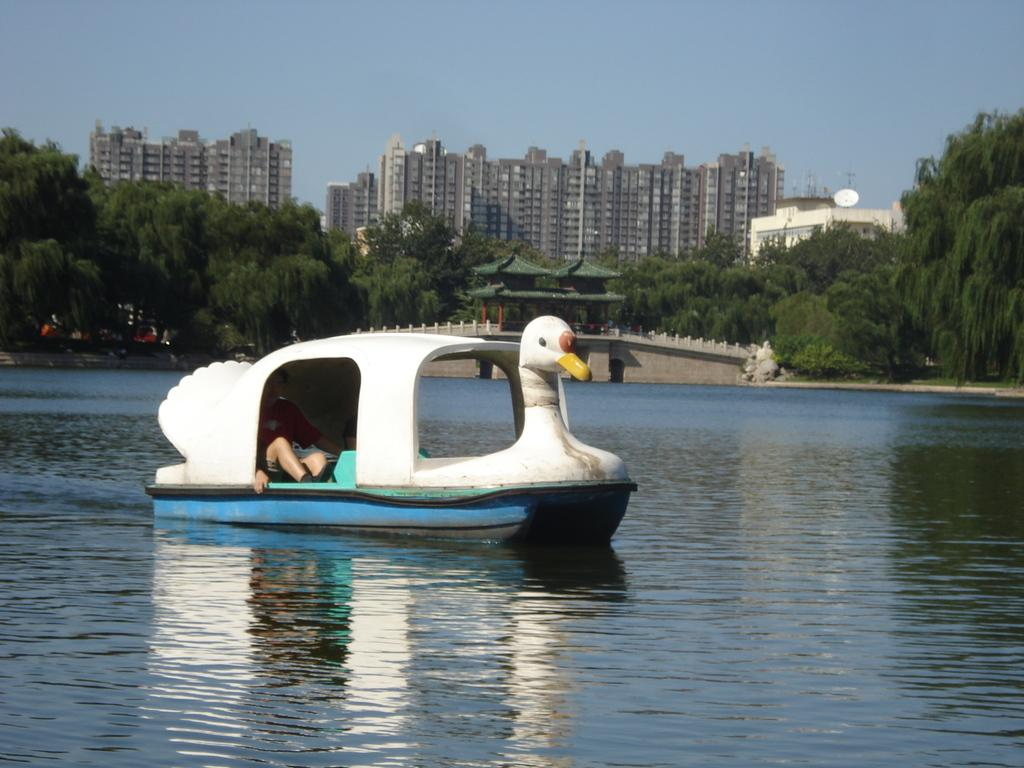What type of natural elements can be seen in the image? There are trees in the image. What type of man-made structures are present in the image? There are buildings in the image. What is the person in the image doing? The person is in a boat in the image. Where is the boat located? The boat is on the water in the image. What can be seen in the background of the image? The sky is visible in the background of the image. What type of alarm can be heard going off in the image? There is no alarm present in the image, as it is a visual representation and does not include sound. Can you see a donkey in the image? There is no donkey present in the image; it features trees, buildings, a person in a boat, and the sky. 